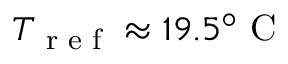<formula> <loc_0><loc_0><loc_500><loc_500>T _ { r e f } \approx 1 9 . 5 ^ { \circ } C</formula> 